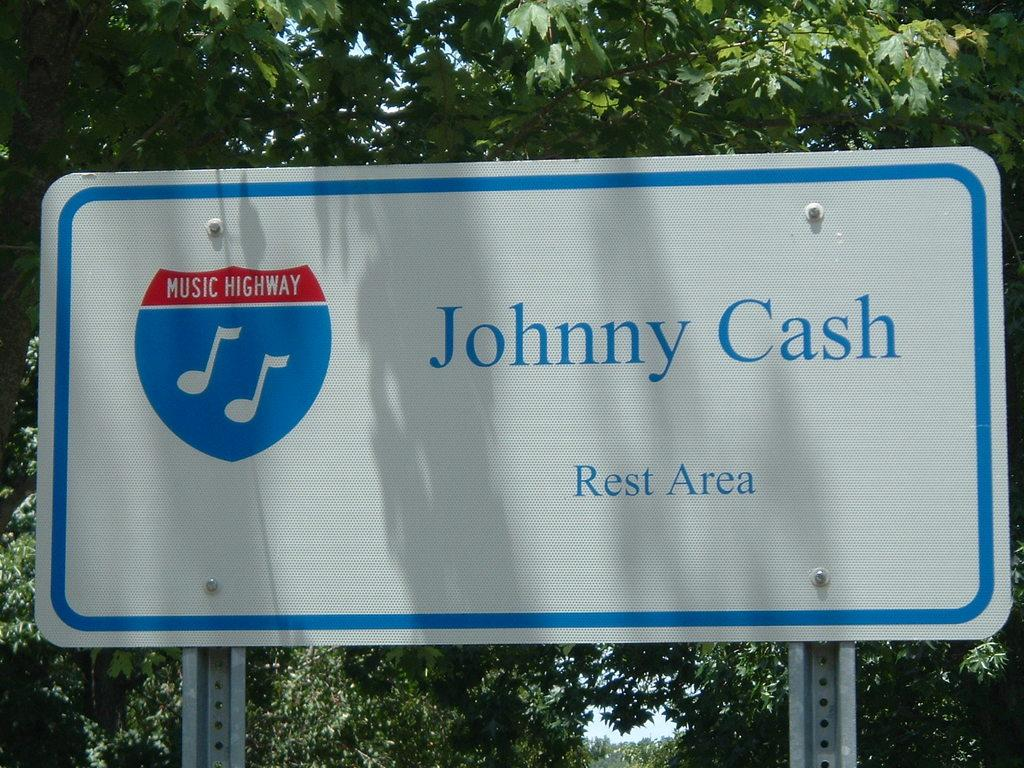What is the main object in the image that is supported by metal poles? There is a board on metal poles in the image. What can be found on the board? The board has text and a logo on it. What can be seen in the background of the image? There are trees visible in the background of the image. What is visible in the sky in the image? The sky is visible in the image. How many boys are depicted as firemen in the image? There are no boys or firemen present in the image. What type of clouds can be seen in the image? The provided facts do not mention any clouds in the image. 